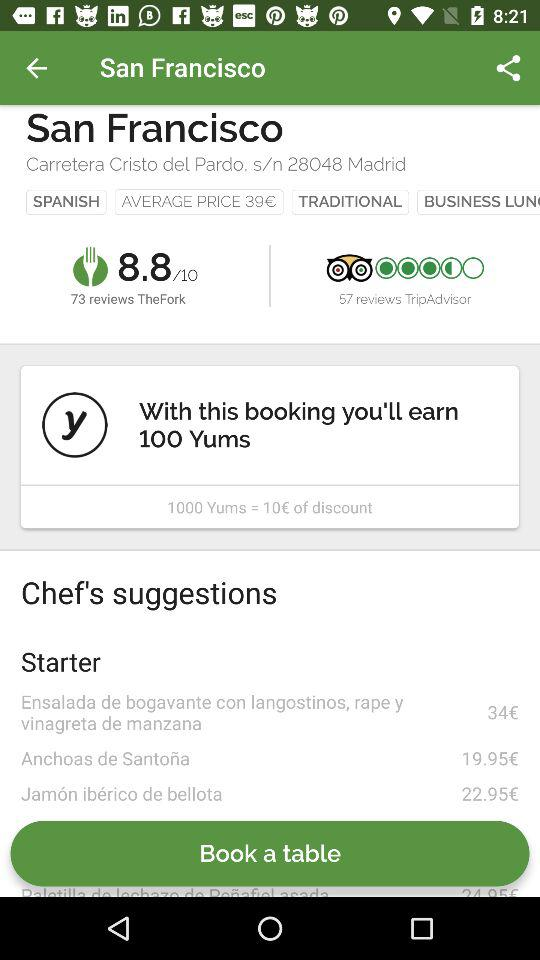What is the location? The location is San Francisco. 